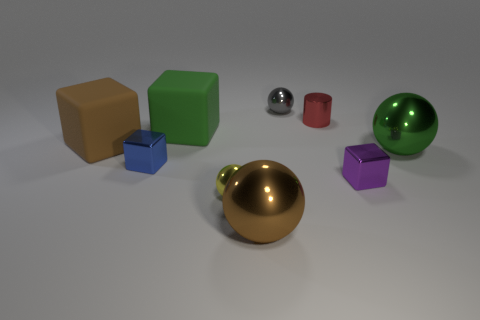What number of other things are the same material as the big green ball?
Give a very brief answer. 6. Is the number of blue metallic blocks less than the number of small spheres?
Offer a very short reply. Yes. There is a red cylinder that is the same size as the yellow metal thing; what is its material?
Provide a short and direct response. Metal. Is the number of tiny gray metal spheres on the left side of the small blue shiny thing less than the number of tiny purple things?
Provide a short and direct response. Yes. What number of tiny yellow things are there?
Make the answer very short. 1. There is a large metal object behind the big metal sphere in front of the tiny yellow metallic thing; what shape is it?
Keep it short and to the point. Sphere. What number of gray objects are behind the small blue object?
Your answer should be compact. 1. Are the green sphere and the big brown thing to the left of the big brown ball made of the same material?
Your answer should be very brief. No. Are there any spheres of the same size as the purple metallic cube?
Give a very brief answer. Yes. Are there the same number of green matte blocks that are in front of the small red cylinder and small gray metallic things?
Keep it short and to the point. Yes. 